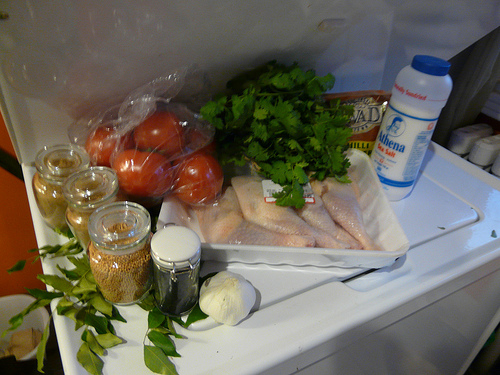<image>
Is the chicken on the washer? Yes. Looking at the image, I can see the chicken is positioned on top of the washer, with the washer providing support. Is the plate on the table? Yes. Looking at the image, I can see the plate is positioned on top of the table, with the table providing support. Is there a chicken in the washer? No. The chicken is not contained within the washer. These objects have a different spatial relationship. Where is the garlic in relation to the spice jar? Is it in the spice jar? No. The garlic is not contained within the spice jar. These objects have a different spatial relationship. 